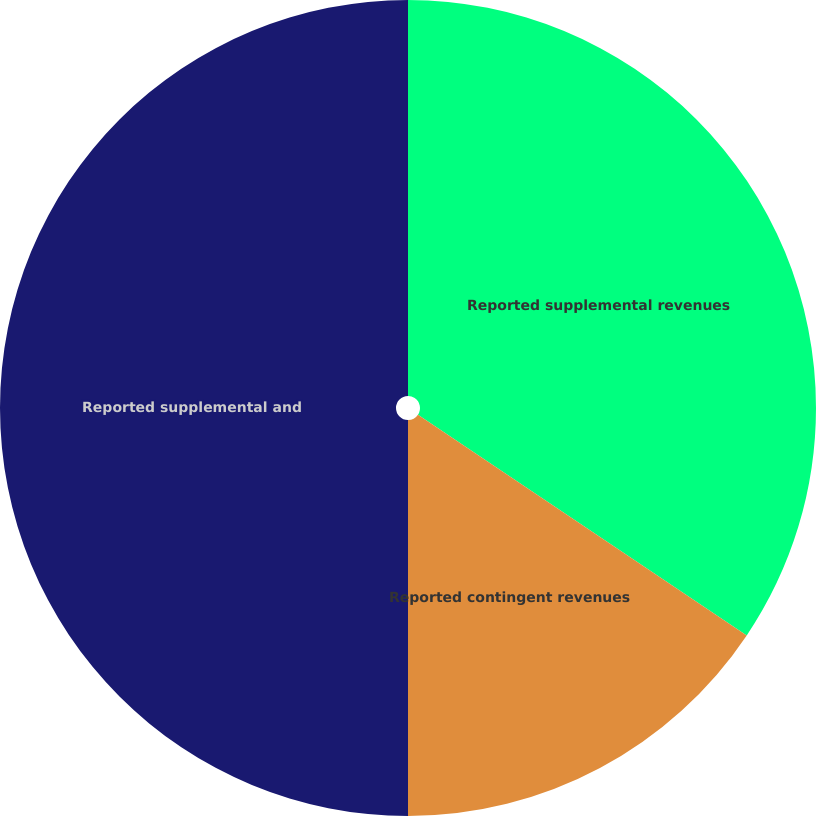Convert chart. <chart><loc_0><loc_0><loc_500><loc_500><pie_chart><fcel>Reported supplemental revenues<fcel>Reported contingent revenues<fcel>Reported supplemental and<nl><fcel>34.41%<fcel>15.59%<fcel>50.0%<nl></chart> 